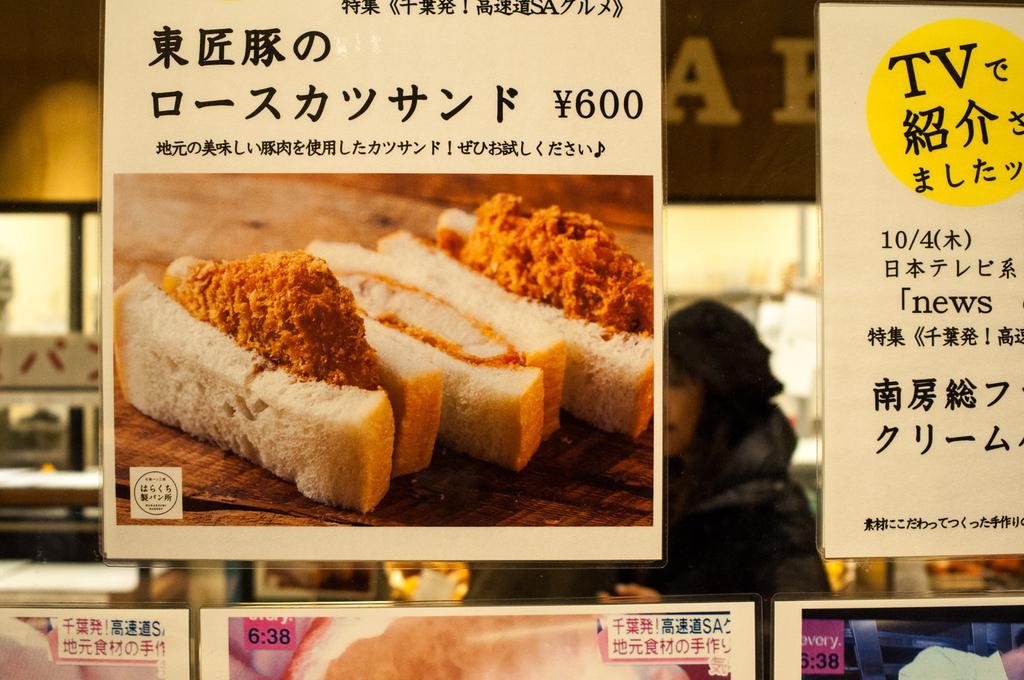In one or two sentences, can you explain what this image depicts? In this image I can see few posts and in the posters I can see few food items, they are in cream, brown and white color. Background I can see few person standing and I can also see few boards attached to the pole. 